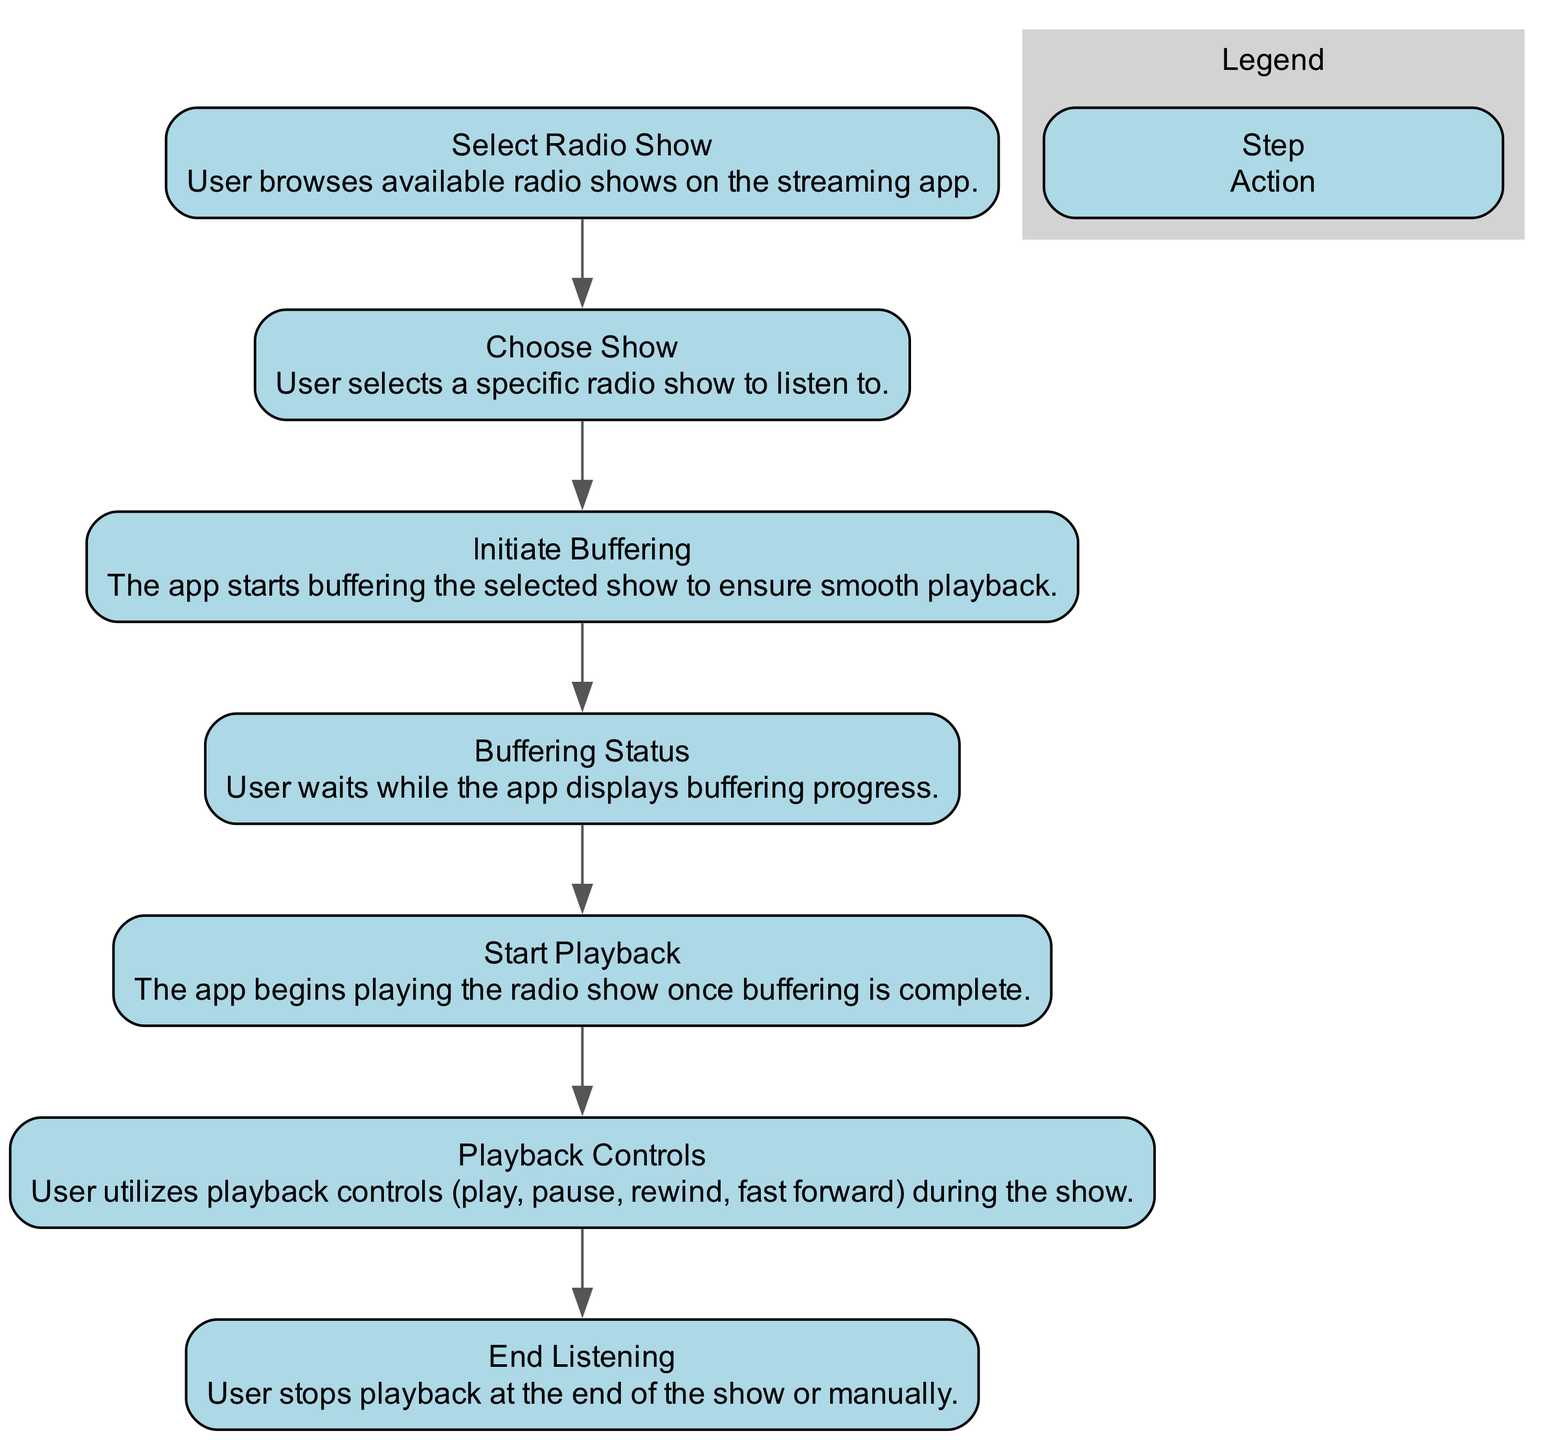What is the first step in the workflow? The workflow starts with the "Select Radio Show" step, which involves the user browsing available radio shows.
Answer: Select Radio Show How many steps are there in the diagram? By counting the individual steps listed in the diagram, we see there are a total of 7 steps outlined for the workflow.
Answer: 7 What does the user do during the "Buffering Status"? During the "Buffering Status", the user waits while the app displays buffering progress.
Answer: Wait What action follows the "Choose Show"? After the "Choose Show" action, the next step is "Initiate Buffering", where the app starts preparing the show for playback.
Answer: Initiate Buffering What is the last step in the workflow? The last step in the workflow is "End Listening", which is when the user stops playback at the end of the show or manually.
Answer: End Listening How does the user control playback during the show? The user utilizes playback controls, which include options to play, pause, rewind, and fast forward during the show.
Answer: Playback controls Which step shows the user's interaction with the app? The "Playback Controls" step indicates the user's interaction with the app by allowing them to engage with various playback functions.
Answer: Playback Controls Which steps involve the user waiting? The steps that involve the user waiting are "Buffering Status" and later directly during playback controls depending on the user's actions.
Answer: Buffering Status What is the purpose of "Initiate Buffering"? The purpose of "Initiate Buffering" is to prepare the selected show for smooth playback by loading data before starting the playback.
Answer: Prepare for playback 